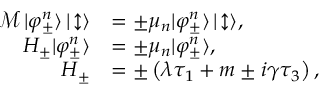<formula> <loc_0><loc_0><loc_500><loc_500>\begin{array} { r l } { \mathcal { M } \, | \varphi _ { \pm } ^ { n } \rangle \, | \, \updownarrow \rangle } & { = \pm \mu _ { n } | \varphi _ { \pm } ^ { n } \rangle \, | \, \updownarrow \rangle , } \\ { H _ { \pm } | \varphi _ { \pm } ^ { n } \rangle } & { = \pm \mu _ { n } | \varphi _ { \pm } ^ { n } \rangle , } \\ { H _ { \pm } } & { = \pm \left ( \lambda \tau _ { 1 } + m \pm i \gamma \tau _ { 3 } \right ) , } \end{array}</formula> 